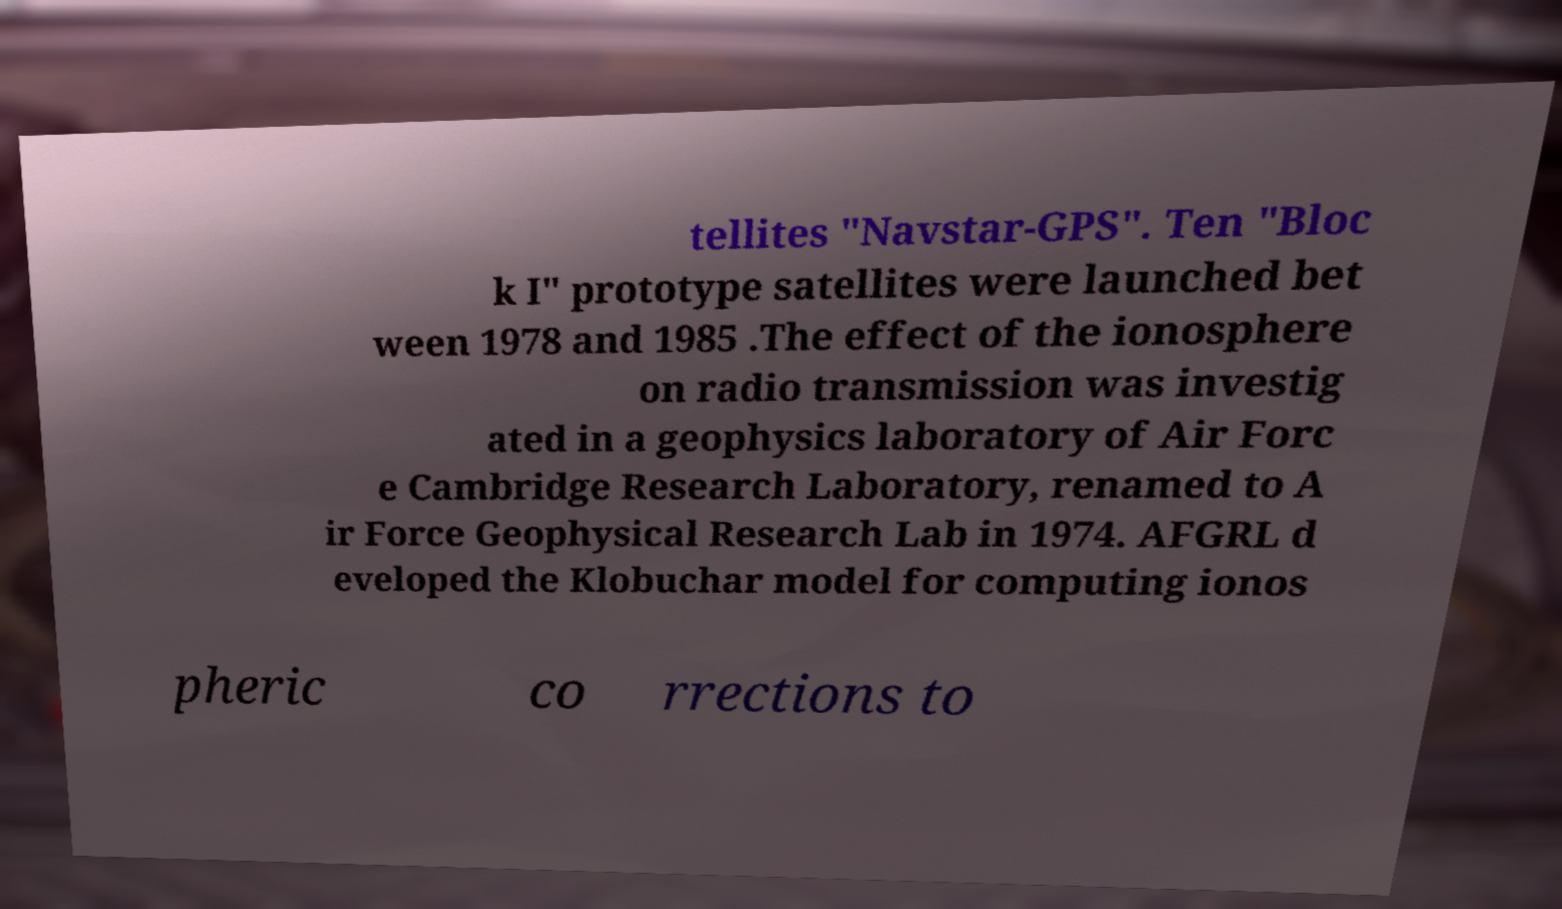Can you accurately transcribe the text from the provided image for me? tellites "Navstar-GPS". Ten "Bloc k I" prototype satellites were launched bet ween 1978 and 1985 .The effect of the ionosphere on radio transmission was investig ated in a geophysics laboratory of Air Forc e Cambridge Research Laboratory, renamed to A ir Force Geophysical Research Lab in 1974. AFGRL d eveloped the Klobuchar model for computing ionos pheric co rrections to 